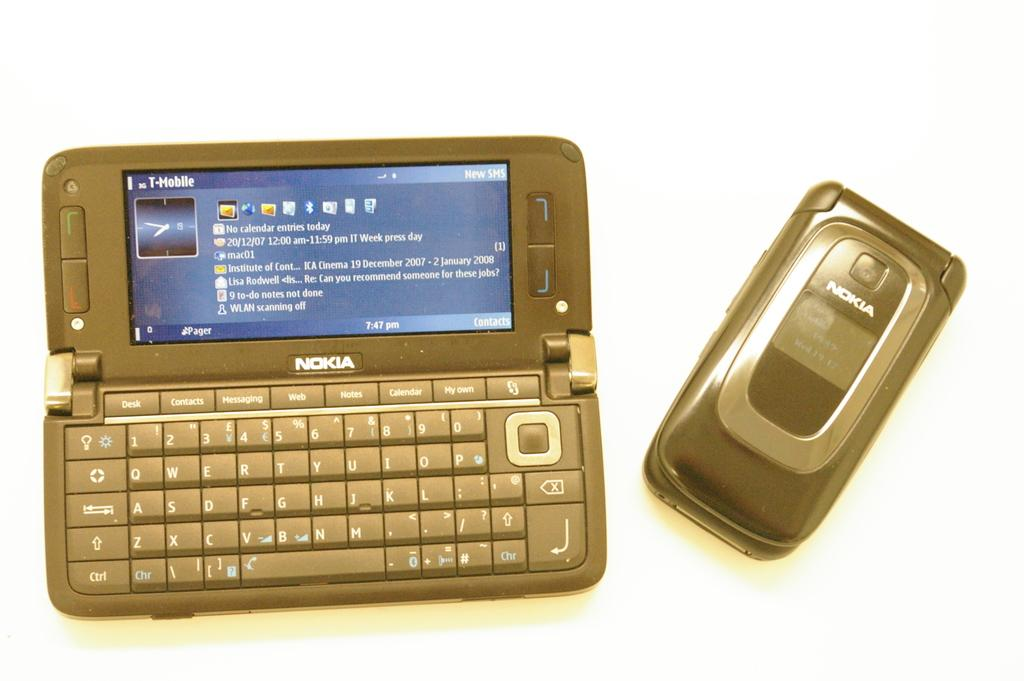<image>
Create a compact narrative representing the image presented. An older model NOKIA flip phone and a phone with a keyboard. 